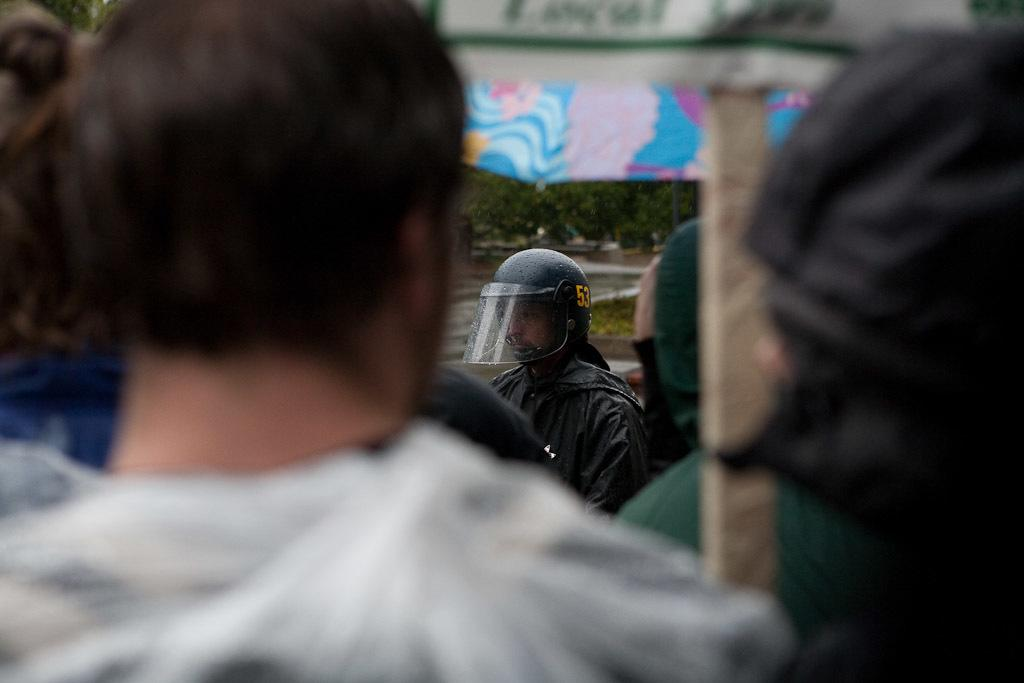How many people are in the image? There is a group of people in the image. Can you describe the clothing of one person in the group? One person in the group is wearing a white shirt. What can be seen in the background of the image? There is an umbrella and trees in the background of the image. What is the appearance of the umbrella? The umbrella has multiple colors. What is the color of the trees in the background? The trees are green. What date is marked on the calendar in the image? There is no calendar present in the image. How many fingers does the person with the white shirt have? The image does not show the person's fingers, so it cannot be determined from the image. 